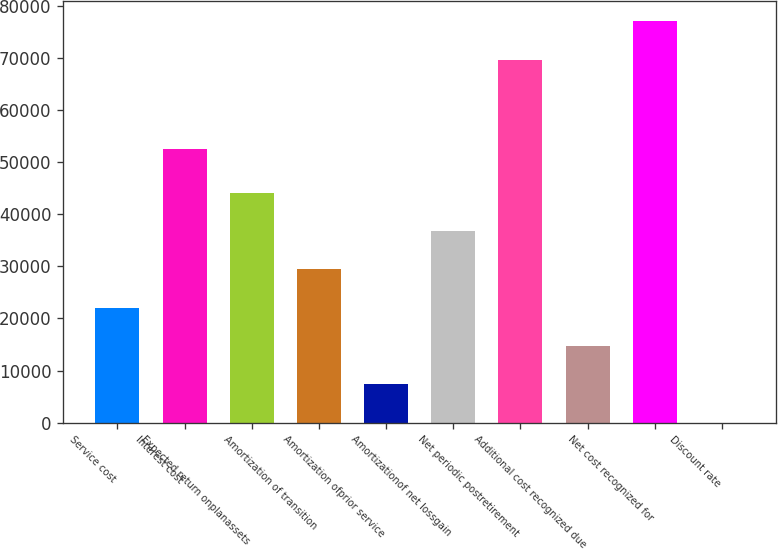<chart> <loc_0><loc_0><loc_500><loc_500><bar_chart><fcel>Service cost<fcel>Interest cost<fcel>Expected return onplanassets<fcel>Amortization of transition<fcel>Amortization ofprior service<fcel>Amortizationof net lossgain<fcel>Net periodic postretirement<fcel>Additional cost recognized due<fcel>Net cost recognized for<fcel>Discount rate<nl><fcel>22078.1<fcel>52604<fcel>44149.9<fcel>29435.4<fcel>7363.53<fcel>36792.6<fcel>69688<fcel>14720.8<fcel>77045.3<fcel>6.25<nl></chart> 